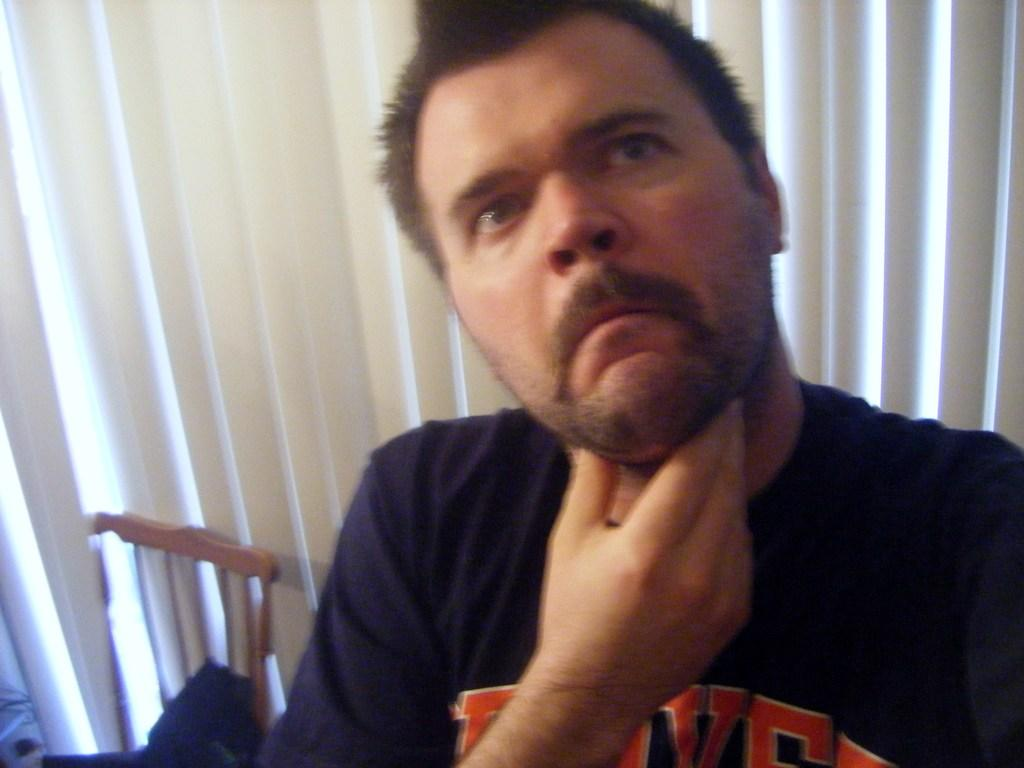What is the person in the image doing near the tree? The transcript does not specify what the person is doing near the tree. What type of tree is near the person in the image? The transcript does not specify the type of tree near the person. Can you describe the river in the background of the image? The transcript only mentions that there is a river flowing in the background, but does not provide any details about its appearance or characteristics. What type of whip is the person using to hit the ground in the image? There is no whip or person hitting the ground present in the image. 